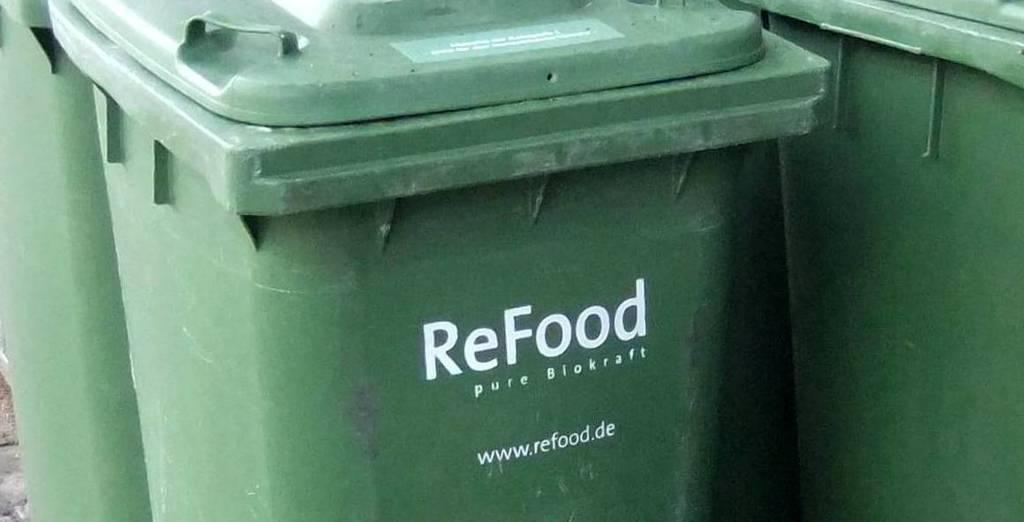<image>
Offer a succinct explanation of the picture presented. The ReFood company is encouraging composting food for BioKraft. 